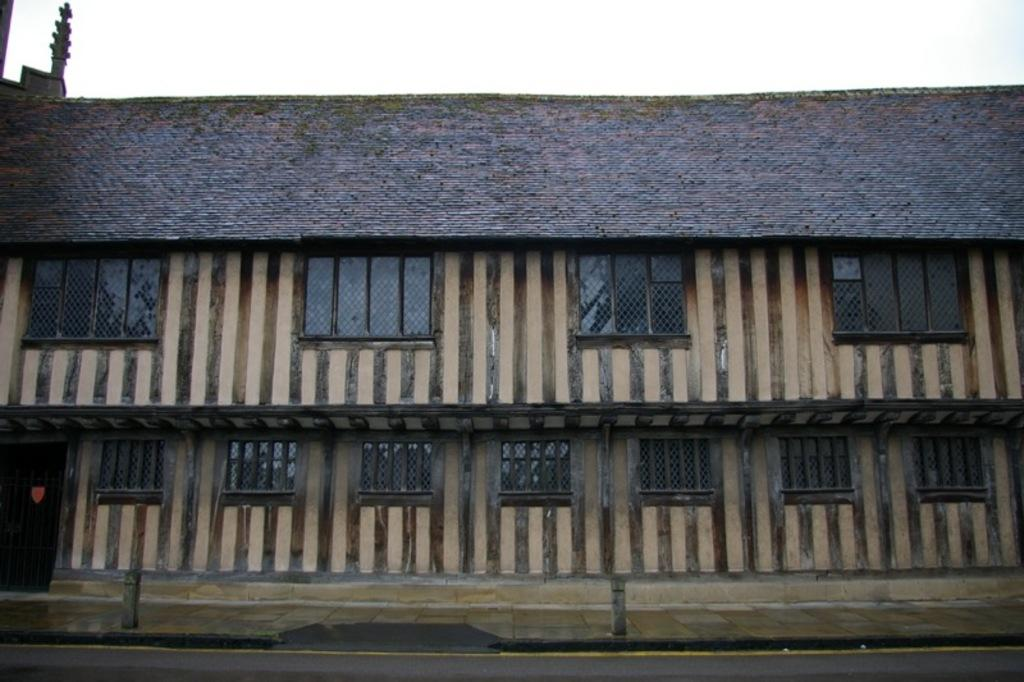What type of structure is present in the image? There is a building in the image. What features can be seen on the building? The building has windows and a door on the left side. Where is the door located on the building? The door is on the left side of the building. What is visible at the top of the image? The sky is visible at the top of the image. What is the condition of the ghost in the image? There is no ghost present in the image, so it is not possible to determine its condition. 